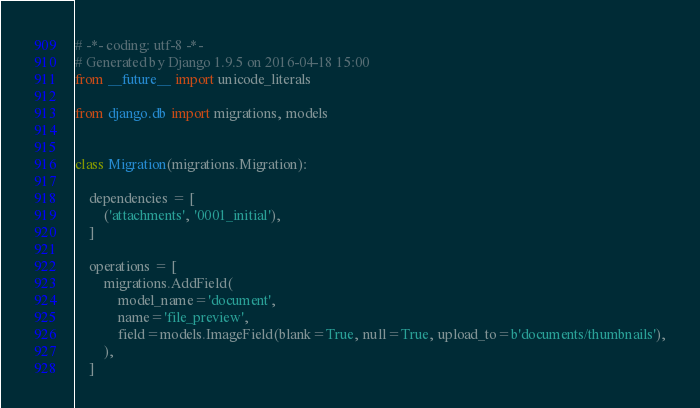Convert code to text. <code><loc_0><loc_0><loc_500><loc_500><_Python_># -*- coding: utf-8 -*-
# Generated by Django 1.9.5 on 2016-04-18 15:00
from __future__ import unicode_literals

from django.db import migrations, models


class Migration(migrations.Migration):

    dependencies = [
        ('attachments', '0001_initial'),
    ]

    operations = [
        migrations.AddField(
            model_name='document',
            name='file_preview',
            field=models.ImageField(blank=True, null=True, upload_to=b'documents/thumbnails'),
        ),
    ]
</code> 